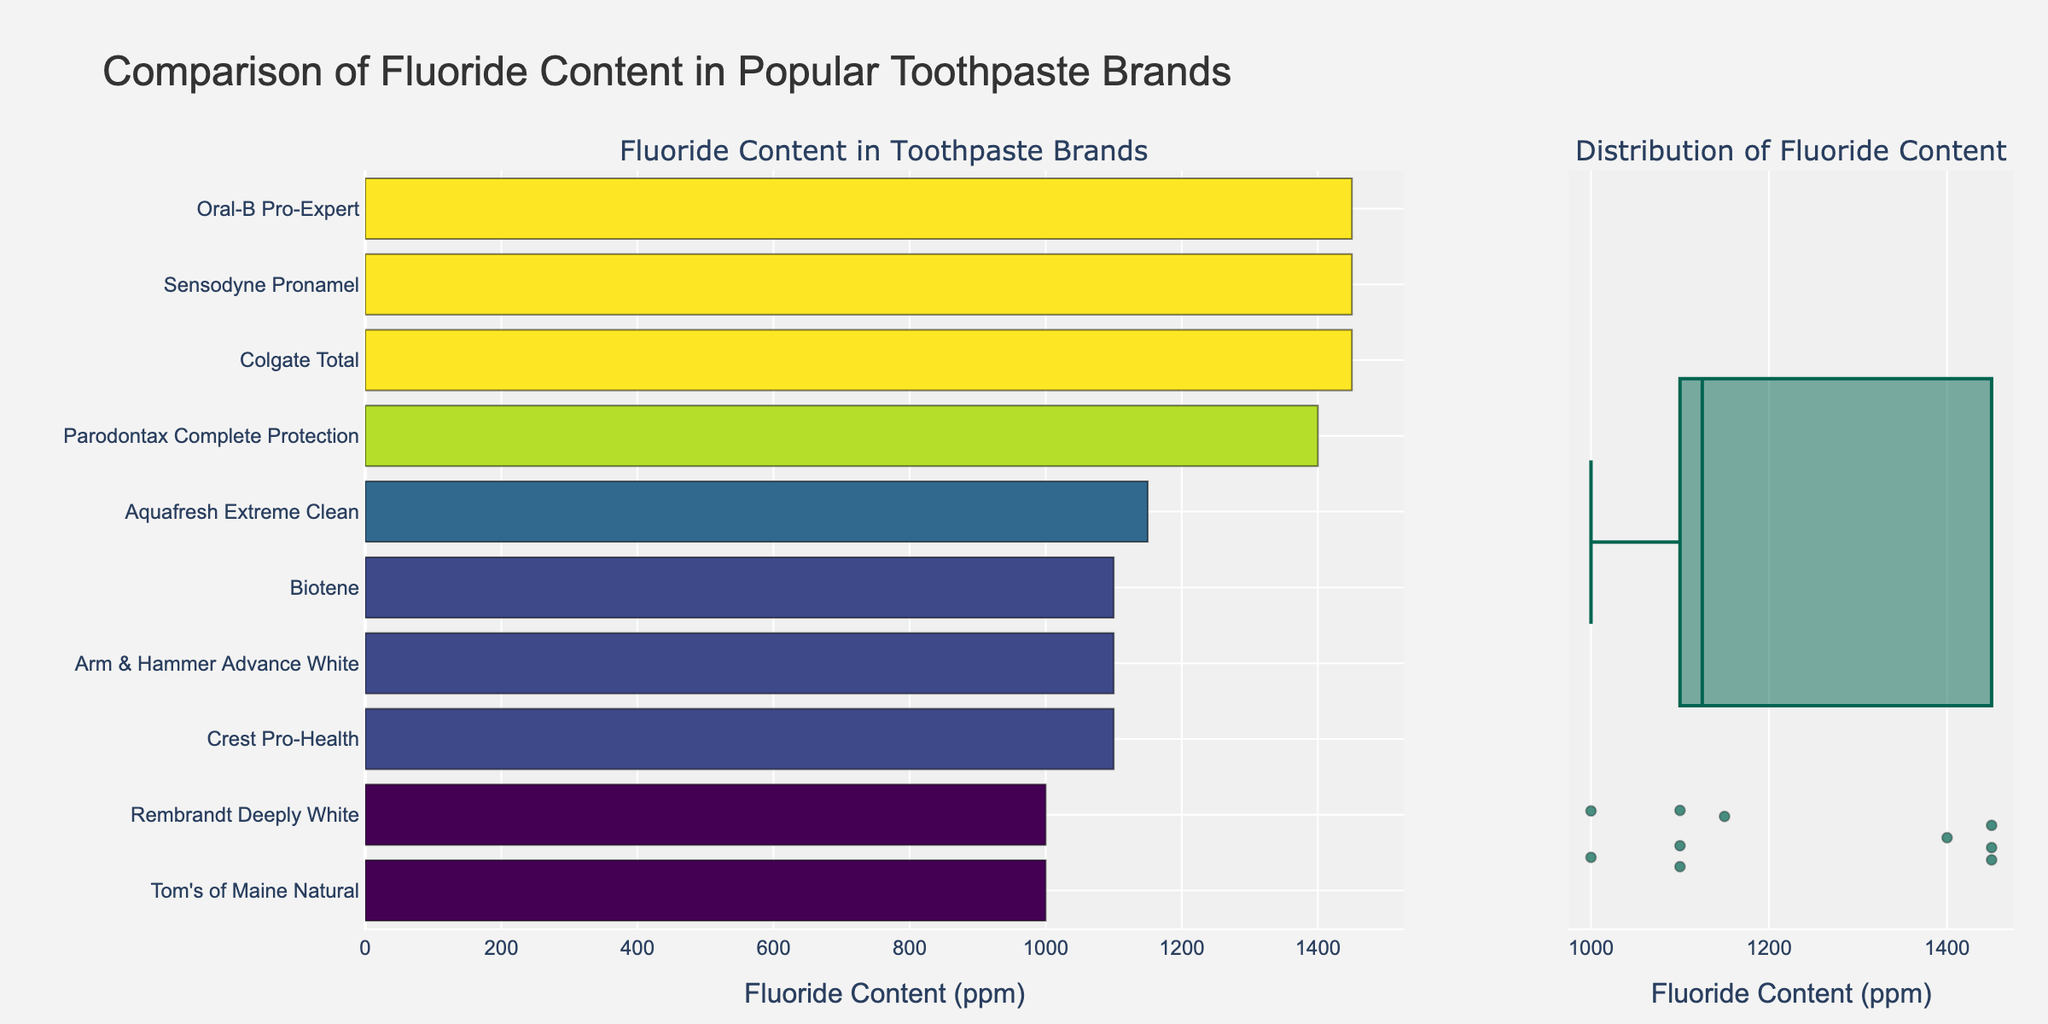What is the title of the figure? The title is usually placed at the top of the figure. In this case, it reads "Comparison of Fluoride Content in Popular Toothpaste Brands".
Answer: Comparison of Fluoride Content in Popular Toothpaste Brands Which toothpaste brands have the highest fluoride content? By examining the horizontal bar chart, we can see that Colgate Total, Sensodyne Pronamel, and Oral-B Pro-Expert have the maximum fluoride content since their bars extend the farthest to the right, indicating 1450 ppm.
Answer: Colgate Total, Sensodyne Pronamel, Oral-B Pro-Expert Which brand has the lowest fluoride content? By looking at the far left of the horizontal bar chart, the shortest bar represents the brand with the lowest fluoride content. In this case, it is Tom's of Maine Natural with 1000 ppm.
Answer: Tom's of Maine Natural What is the range of fluoride content among the toothpaste brands? To find the range, we subtract the smallest value from the largest value in the dataset. From the bar chart, the lowest is 1000 ppm (Tom's of Maine Natural, Rembrandt Deeply White) and the highest is 1450 ppm. Thus, the range is 1450 - 1000 = 450 ppm.
Answer: 450 ppm How many brands have fluoride content above 1200 ppm? Identifying the bars that extend beyond 1200 ppm in the horizontal bar chart, we see that there are four brands: Colgate Total, Sensodyne Pronamel, Oral-B Pro-Expert, and Parodontax Complete Protection.
Answer: 4 Which brand has exactly 1400 ppm of fluoride content? By looking at the horizontal bar chart, the bar that stops at 1400 ppm belongs to Parodontax Complete Protection.
Answer: Parodontax Complete Protection What's the median fluoride content of these toothpaste brands? The median value is the middle number in a sorted dataset. With 10 brands, the fifth and sixth highest values after sorting are both 1100 ppm. Therefore, the median is the average of these values: (1100 + 1100) / 2 = 1100 ppm.
Answer: 1100 ppm What is the interquartile range (IQR) of the fluoride content? The IQR is the difference between the 75th percentile (Q3) and the 25th percentile (Q1). For 10 data points, Q1 is the average of the 3rd and 4th values (1100 + 1100) / 2 = 1100 ppm, and Q3 is the average of the 7th and 8th values (1450 + 1400) / 2 = 1425 ppm. So, IQR = 1425 - 1100 = 325 ppm.
Answer: 325 ppm Which toothpaste brand has the second lowest fluoride content? By examining the horizontal bar chart, we can determine that the second shortest bar represents Rembrandt Deeply White, which has the second lowest fluoride content of 1000 ppm.
Answer: Rembrandt Deeply White 